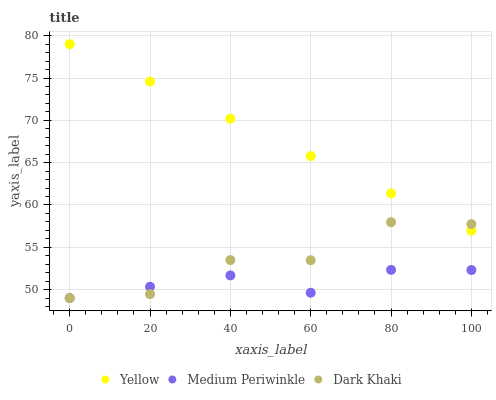Does Medium Periwinkle have the minimum area under the curve?
Answer yes or no. Yes. Does Yellow have the maximum area under the curve?
Answer yes or no. Yes. Does Yellow have the minimum area under the curve?
Answer yes or no. No. Does Medium Periwinkle have the maximum area under the curve?
Answer yes or no. No. Is Yellow the smoothest?
Answer yes or no. Yes. Is Dark Khaki the roughest?
Answer yes or no. Yes. Is Medium Periwinkle the smoothest?
Answer yes or no. No. Is Medium Periwinkle the roughest?
Answer yes or no. No. Does Dark Khaki have the lowest value?
Answer yes or no. Yes. Does Yellow have the lowest value?
Answer yes or no. No. Does Yellow have the highest value?
Answer yes or no. Yes. Does Medium Periwinkle have the highest value?
Answer yes or no. No. Is Medium Periwinkle less than Yellow?
Answer yes or no. Yes. Is Yellow greater than Medium Periwinkle?
Answer yes or no. Yes. Does Medium Periwinkle intersect Dark Khaki?
Answer yes or no. Yes. Is Medium Periwinkle less than Dark Khaki?
Answer yes or no. No. Is Medium Periwinkle greater than Dark Khaki?
Answer yes or no. No. Does Medium Periwinkle intersect Yellow?
Answer yes or no. No. 